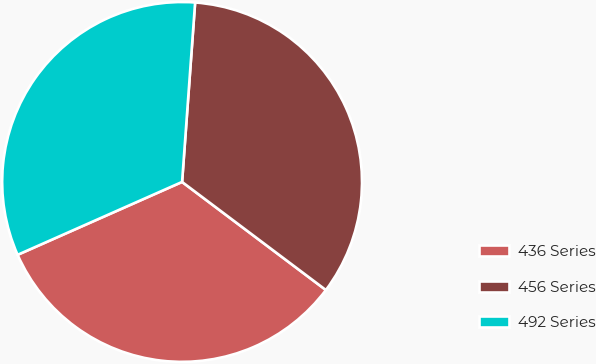Convert chart. <chart><loc_0><loc_0><loc_500><loc_500><pie_chart><fcel>436 Series<fcel>456 Series<fcel>492 Series<nl><fcel>33.1%<fcel>34.1%<fcel>32.79%<nl></chart> 